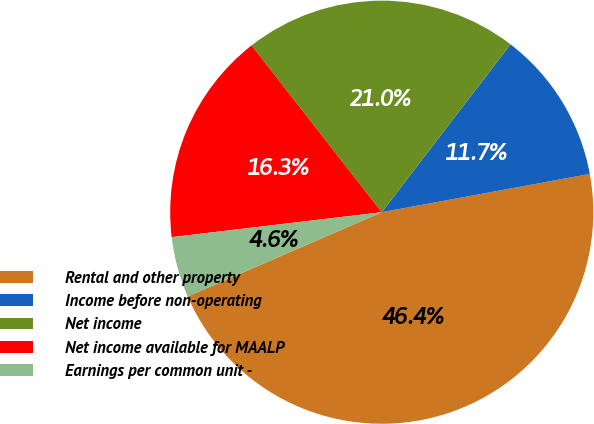<chart> <loc_0><loc_0><loc_500><loc_500><pie_chart><fcel>Rental and other property<fcel>Income before non-operating<fcel>Net income<fcel>Net income available for MAALP<fcel>Earnings per common unit -<nl><fcel>46.38%<fcel>11.69%<fcel>20.97%<fcel>16.33%<fcel>4.64%<nl></chart> 